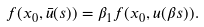Convert formula to latex. <formula><loc_0><loc_0><loc_500><loc_500>f ( x _ { 0 } , \bar { u } ( s ) ) = \beta _ { 1 } f ( x _ { 0 } , u ( \beta s ) ) .</formula> 